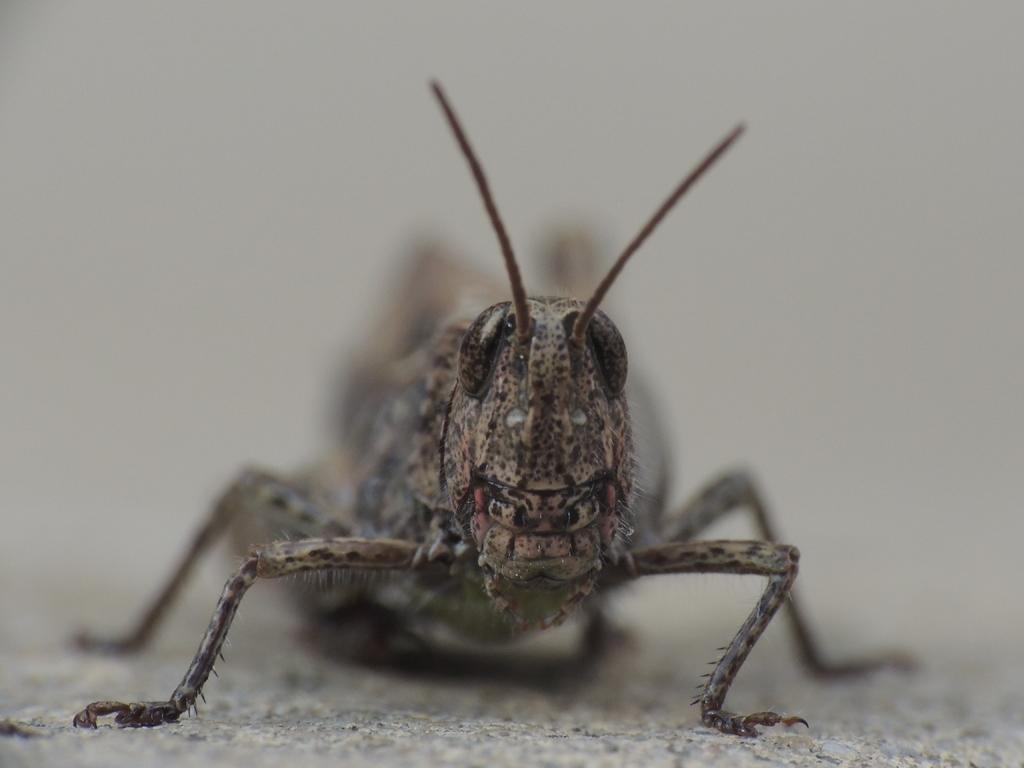What type of creature can be seen in the image? There is an insect in the image. Where is the insect located in the image? The insect is on the ground. What grade is the insect in the image? The concept of grades does not apply to insects, as they are not students or have any educational system. 